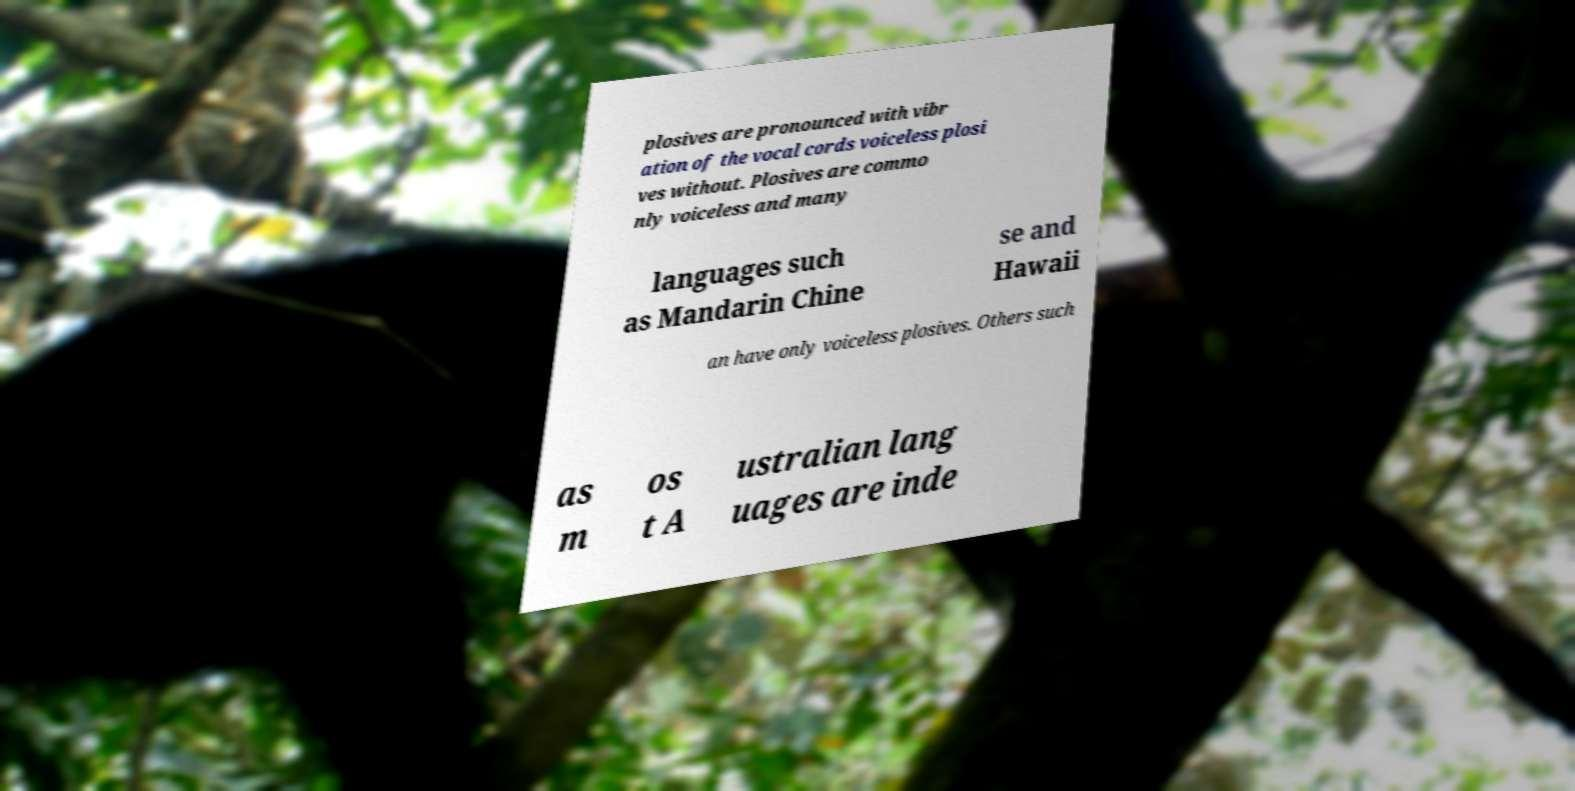For documentation purposes, I need the text within this image transcribed. Could you provide that? plosives are pronounced with vibr ation of the vocal cords voiceless plosi ves without. Plosives are commo nly voiceless and many languages such as Mandarin Chine se and Hawaii an have only voiceless plosives. Others such as m os t A ustralian lang uages are inde 